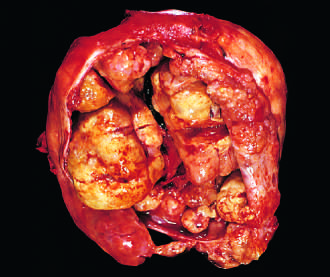s borderline serous cystadenoma opened to show a large, bulky tumor mass?
Answer the question using a single word or phrase. No 